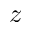Convert formula to latex. <formula><loc_0><loc_0><loc_500><loc_500>z</formula> 